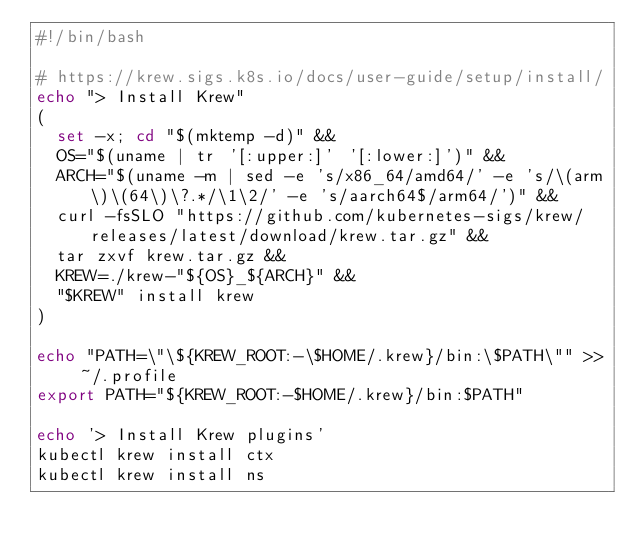<code> <loc_0><loc_0><loc_500><loc_500><_Bash_>#!/bin/bash

# https://krew.sigs.k8s.io/docs/user-guide/setup/install/
echo "> Install Krew"
(
  set -x; cd "$(mktemp -d)" &&
  OS="$(uname | tr '[:upper:]' '[:lower:]')" &&
  ARCH="$(uname -m | sed -e 's/x86_64/amd64/' -e 's/\(arm\)\(64\)\?.*/\1\2/' -e 's/aarch64$/arm64/')" &&
  curl -fsSLO "https://github.com/kubernetes-sigs/krew/releases/latest/download/krew.tar.gz" &&
  tar zxvf krew.tar.gz &&
  KREW=./krew-"${OS}_${ARCH}" &&
  "$KREW" install krew
)

echo "PATH=\"\${KREW_ROOT:-\$HOME/.krew}/bin:\$PATH\"" >> ~/.profile
export PATH="${KREW_ROOT:-$HOME/.krew}/bin:$PATH"

echo '> Install Krew plugins'
kubectl krew install ctx
kubectl krew install ns
</code> 